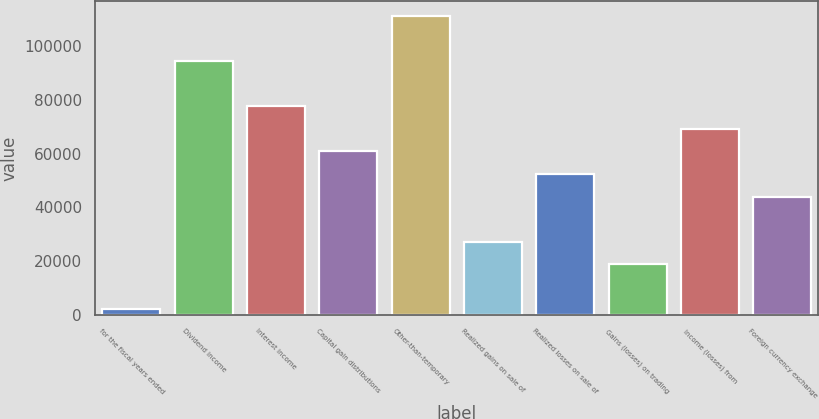<chart> <loc_0><loc_0><loc_500><loc_500><bar_chart><fcel>for the fiscal years ended<fcel>Dividend income<fcel>Interest income<fcel>Capital gain distributions<fcel>Other-than-temporary<fcel>Realized gains on sale of<fcel>Realized losses on sale of<fcel>Gains (losses) on trading<fcel>Income (losses) from<fcel>Foreign currency exchange<nl><fcel>2009<fcel>94411.2<fcel>77610.8<fcel>60810.4<fcel>111212<fcel>27209.6<fcel>52410.2<fcel>18809.4<fcel>69210.6<fcel>44010<nl></chart> 